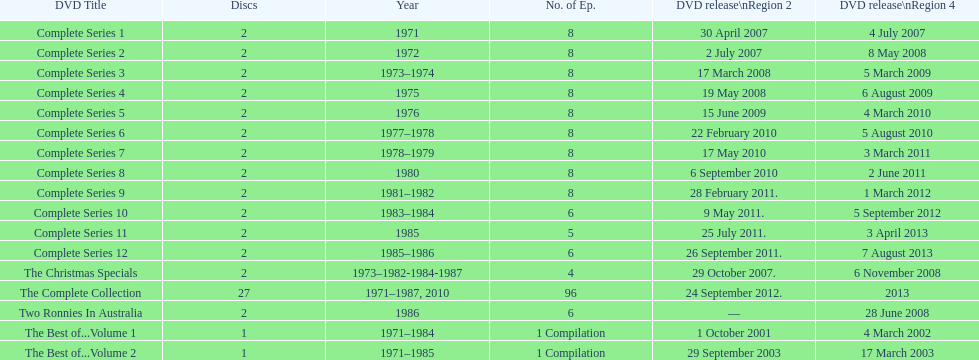Can it be confirmed that each season of "the two ronnies" television program contained more than 10 episodes? False. 